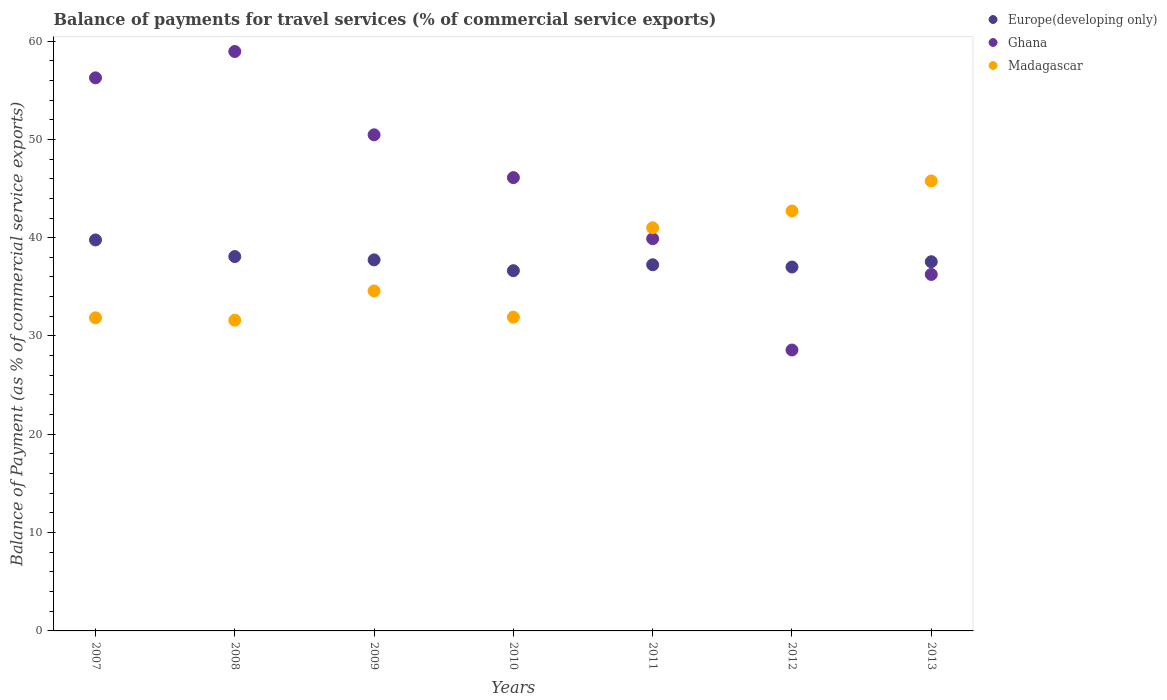How many different coloured dotlines are there?
Give a very brief answer. 3. Is the number of dotlines equal to the number of legend labels?
Provide a succinct answer. Yes. What is the balance of payments for travel services in Europe(developing only) in 2012?
Your answer should be very brief. 37.02. Across all years, what is the maximum balance of payments for travel services in Madagascar?
Provide a succinct answer. 45.77. Across all years, what is the minimum balance of payments for travel services in Europe(developing only)?
Keep it short and to the point. 36.64. In which year was the balance of payments for travel services in Ghana maximum?
Your answer should be very brief. 2008. What is the total balance of payments for travel services in Madagascar in the graph?
Ensure brevity in your answer.  259.44. What is the difference between the balance of payments for travel services in Ghana in 2007 and that in 2009?
Your response must be concise. 5.8. What is the difference between the balance of payments for travel services in Ghana in 2010 and the balance of payments for travel services in Madagascar in 2009?
Make the answer very short. 11.53. What is the average balance of payments for travel services in Madagascar per year?
Your response must be concise. 37.06. In the year 2009, what is the difference between the balance of payments for travel services in Ghana and balance of payments for travel services in Madagascar?
Your response must be concise. 15.88. What is the ratio of the balance of payments for travel services in Ghana in 2007 to that in 2012?
Make the answer very short. 1.97. Is the balance of payments for travel services in Madagascar in 2009 less than that in 2010?
Your response must be concise. No. What is the difference between the highest and the second highest balance of payments for travel services in Ghana?
Give a very brief answer. 2.68. What is the difference between the highest and the lowest balance of payments for travel services in Europe(developing only)?
Your answer should be very brief. 3.13. Is the sum of the balance of payments for travel services in Ghana in 2011 and 2012 greater than the maximum balance of payments for travel services in Madagascar across all years?
Your answer should be compact. Yes. Is it the case that in every year, the sum of the balance of payments for travel services in Madagascar and balance of payments for travel services in Ghana  is greater than the balance of payments for travel services in Europe(developing only)?
Give a very brief answer. Yes. Is the balance of payments for travel services in Madagascar strictly greater than the balance of payments for travel services in Europe(developing only) over the years?
Your response must be concise. No. Is the balance of payments for travel services in Europe(developing only) strictly less than the balance of payments for travel services in Madagascar over the years?
Offer a terse response. No. How many years are there in the graph?
Provide a succinct answer. 7. What is the difference between two consecutive major ticks on the Y-axis?
Your response must be concise. 10. Does the graph contain any zero values?
Offer a very short reply. No. Does the graph contain grids?
Provide a short and direct response. No. Where does the legend appear in the graph?
Provide a succinct answer. Top right. How are the legend labels stacked?
Give a very brief answer. Vertical. What is the title of the graph?
Offer a terse response. Balance of payments for travel services (% of commercial service exports). Does "Uruguay" appear as one of the legend labels in the graph?
Offer a very short reply. No. What is the label or title of the X-axis?
Give a very brief answer. Years. What is the label or title of the Y-axis?
Offer a terse response. Balance of Payment (as % of commercial service exports). What is the Balance of Payment (as % of commercial service exports) in Europe(developing only) in 2007?
Your answer should be compact. 39.77. What is the Balance of Payment (as % of commercial service exports) of Ghana in 2007?
Provide a succinct answer. 56.26. What is the Balance of Payment (as % of commercial service exports) of Madagascar in 2007?
Offer a very short reply. 31.85. What is the Balance of Payment (as % of commercial service exports) of Europe(developing only) in 2008?
Provide a succinct answer. 38.08. What is the Balance of Payment (as % of commercial service exports) in Ghana in 2008?
Give a very brief answer. 58.94. What is the Balance of Payment (as % of commercial service exports) in Madagascar in 2008?
Provide a succinct answer. 31.6. What is the Balance of Payment (as % of commercial service exports) of Europe(developing only) in 2009?
Ensure brevity in your answer.  37.74. What is the Balance of Payment (as % of commercial service exports) in Ghana in 2009?
Keep it short and to the point. 50.46. What is the Balance of Payment (as % of commercial service exports) of Madagascar in 2009?
Give a very brief answer. 34.58. What is the Balance of Payment (as % of commercial service exports) in Europe(developing only) in 2010?
Provide a succinct answer. 36.64. What is the Balance of Payment (as % of commercial service exports) of Ghana in 2010?
Your response must be concise. 46.11. What is the Balance of Payment (as % of commercial service exports) of Madagascar in 2010?
Provide a short and direct response. 31.92. What is the Balance of Payment (as % of commercial service exports) of Europe(developing only) in 2011?
Ensure brevity in your answer.  37.24. What is the Balance of Payment (as % of commercial service exports) of Ghana in 2011?
Keep it short and to the point. 39.89. What is the Balance of Payment (as % of commercial service exports) of Madagascar in 2011?
Your answer should be very brief. 41.01. What is the Balance of Payment (as % of commercial service exports) in Europe(developing only) in 2012?
Offer a very short reply. 37.02. What is the Balance of Payment (as % of commercial service exports) of Ghana in 2012?
Your answer should be compact. 28.57. What is the Balance of Payment (as % of commercial service exports) of Madagascar in 2012?
Offer a terse response. 42.72. What is the Balance of Payment (as % of commercial service exports) in Europe(developing only) in 2013?
Give a very brief answer. 37.55. What is the Balance of Payment (as % of commercial service exports) in Ghana in 2013?
Keep it short and to the point. 36.26. What is the Balance of Payment (as % of commercial service exports) in Madagascar in 2013?
Keep it short and to the point. 45.77. Across all years, what is the maximum Balance of Payment (as % of commercial service exports) of Europe(developing only)?
Provide a short and direct response. 39.77. Across all years, what is the maximum Balance of Payment (as % of commercial service exports) in Ghana?
Offer a terse response. 58.94. Across all years, what is the maximum Balance of Payment (as % of commercial service exports) in Madagascar?
Your answer should be compact. 45.77. Across all years, what is the minimum Balance of Payment (as % of commercial service exports) of Europe(developing only)?
Your answer should be compact. 36.64. Across all years, what is the minimum Balance of Payment (as % of commercial service exports) in Ghana?
Give a very brief answer. 28.57. Across all years, what is the minimum Balance of Payment (as % of commercial service exports) in Madagascar?
Make the answer very short. 31.6. What is the total Balance of Payment (as % of commercial service exports) in Europe(developing only) in the graph?
Your answer should be compact. 264.05. What is the total Balance of Payment (as % of commercial service exports) in Ghana in the graph?
Provide a short and direct response. 316.49. What is the total Balance of Payment (as % of commercial service exports) of Madagascar in the graph?
Give a very brief answer. 259.44. What is the difference between the Balance of Payment (as % of commercial service exports) of Europe(developing only) in 2007 and that in 2008?
Keep it short and to the point. 1.69. What is the difference between the Balance of Payment (as % of commercial service exports) in Ghana in 2007 and that in 2008?
Make the answer very short. -2.68. What is the difference between the Balance of Payment (as % of commercial service exports) in Madagascar in 2007 and that in 2008?
Provide a succinct answer. 0.24. What is the difference between the Balance of Payment (as % of commercial service exports) of Europe(developing only) in 2007 and that in 2009?
Your answer should be compact. 2.03. What is the difference between the Balance of Payment (as % of commercial service exports) in Ghana in 2007 and that in 2009?
Your answer should be compact. 5.8. What is the difference between the Balance of Payment (as % of commercial service exports) in Madagascar in 2007 and that in 2009?
Ensure brevity in your answer.  -2.73. What is the difference between the Balance of Payment (as % of commercial service exports) in Europe(developing only) in 2007 and that in 2010?
Make the answer very short. 3.13. What is the difference between the Balance of Payment (as % of commercial service exports) of Ghana in 2007 and that in 2010?
Keep it short and to the point. 10.15. What is the difference between the Balance of Payment (as % of commercial service exports) in Madagascar in 2007 and that in 2010?
Keep it short and to the point. -0.07. What is the difference between the Balance of Payment (as % of commercial service exports) of Europe(developing only) in 2007 and that in 2011?
Your answer should be very brief. 2.53. What is the difference between the Balance of Payment (as % of commercial service exports) of Ghana in 2007 and that in 2011?
Your response must be concise. 16.36. What is the difference between the Balance of Payment (as % of commercial service exports) of Madagascar in 2007 and that in 2011?
Provide a succinct answer. -9.16. What is the difference between the Balance of Payment (as % of commercial service exports) of Europe(developing only) in 2007 and that in 2012?
Make the answer very short. 2.75. What is the difference between the Balance of Payment (as % of commercial service exports) of Ghana in 2007 and that in 2012?
Your answer should be compact. 27.68. What is the difference between the Balance of Payment (as % of commercial service exports) in Madagascar in 2007 and that in 2012?
Your response must be concise. -10.87. What is the difference between the Balance of Payment (as % of commercial service exports) in Europe(developing only) in 2007 and that in 2013?
Give a very brief answer. 2.22. What is the difference between the Balance of Payment (as % of commercial service exports) in Ghana in 2007 and that in 2013?
Give a very brief answer. 20. What is the difference between the Balance of Payment (as % of commercial service exports) of Madagascar in 2007 and that in 2013?
Your response must be concise. -13.92. What is the difference between the Balance of Payment (as % of commercial service exports) of Europe(developing only) in 2008 and that in 2009?
Offer a very short reply. 0.34. What is the difference between the Balance of Payment (as % of commercial service exports) in Ghana in 2008 and that in 2009?
Make the answer very short. 8.47. What is the difference between the Balance of Payment (as % of commercial service exports) in Madagascar in 2008 and that in 2009?
Your response must be concise. -2.97. What is the difference between the Balance of Payment (as % of commercial service exports) of Europe(developing only) in 2008 and that in 2010?
Give a very brief answer. 1.44. What is the difference between the Balance of Payment (as % of commercial service exports) in Ghana in 2008 and that in 2010?
Your response must be concise. 12.83. What is the difference between the Balance of Payment (as % of commercial service exports) of Madagascar in 2008 and that in 2010?
Your response must be concise. -0.31. What is the difference between the Balance of Payment (as % of commercial service exports) of Europe(developing only) in 2008 and that in 2011?
Your answer should be compact. 0.84. What is the difference between the Balance of Payment (as % of commercial service exports) of Ghana in 2008 and that in 2011?
Your answer should be very brief. 19.04. What is the difference between the Balance of Payment (as % of commercial service exports) in Madagascar in 2008 and that in 2011?
Your answer should be compact. -9.4. What is the difference between the Balance of Payment (as % of commercial service exports) of Europe(developing only) in 2008 and that in 2012?
Give a very brief answer. 1.06. What is the difference between the Balance of Payment (as % of commercial service exports) of Ghana in 2008 and that in 2012?
Offer a very short reply. 30.36. What is the difference between the Balance of Payment (as % of commercial service exports) in Madagascar in 2008 and that in 2012?
Give a very brief answer. -11.11. What is the difference between the Balance of Payment (as % of commercial service exports) in Europe(developing only) in 2008 and that in 2013?
Give a very brief answer. 0.53. What is the difference between the Balance of Payment (as % of commercial service exports) in Ghana in 2008 and that in 2013?
Make the answer very short. 22.68. What is the difference between the Balance of Payment (as % of commercial service exports) in Madagascar in 2008 and that in 2013?
Ensure brevity in your answer.  -14.17. What is the difference between the Balance of Payment (as % of commercial service exports) in Europe(developing only) in 2009 and that in 2010?
Give a very brief answer. 1.1. What is the difference between the Balance of Payment (as % of commercial service exports) of Ghana in 2009 and that in 2010?
Provide a succinct answer. 4.35. What is the difference between the Balance of Payment (as % of commercial service exports) in Madagascar in 2009 and that in 2010?
Offer a very short reply. 2.66. What is the difference between the Balance of Payment (as % of commercial service exports) of Europe(developing only) in 2009 and that in 2011?
Offer a very short reply. 0.5. What is the difference between the Balance of Payment (as % of commercial service exports) of Ghana in 2009 and that in 2011?
Ensure brevity in your answer.  10.57. What is the difference between the Balance of Payment (as % of commercial service exports) of Madagascar in 2009 and that in 2011?
Make the answer very short. -6.43. What is the difference between the Balance of Payment (as % of commercial service exports) of Europe(developing only) in 2009 and that in 2012?
Make the answer very short. 0.73. What is the difference between the Balance of Payment (as % of commercial service exports) in Ghana in 2009 and that in 2012?
Your answer should be compact. 21.89. What is the difference between the Balance of Payment (as % of commercial service exports) of Madagascar in 2009 and that in 2012?
Keep it short and to the point. -8.14. What is the difference between the Balance of Payment (as % of commercial service exports) of Europe(developing only) in 2009 and that in 2013?
Give a very brief answer. 0.19. What is the difference between the Balance of Payment (as % of commercial service exports) of Ghana in 2009 and that in 2013?
Give a very brief answer. 14.2. What is the difference between the Balance of Payment (as % of commercial service exports) of Madagascar in 2009 and that in 2013?
Give a very brief answer. -11.19. What is the difference between the Balance of Payment (as % of commercial service exports) in Europe(developing only) in 2010 and that in 2011?
Ensure brevity in your answer.  -0.6. What is the difference between the Balance of Payment (as % of commercial service exports) of Ghana in 2010 and that in 2011?
Provide a short and direct response. 6.21. What is the difference between the Balance of Payment (as % of commercial service exports) in Madagascar in 2010 and that in 2011?
Make the answer very short. -9.09. What is the difference between the Balance of Payment (as % of commercial service exports) in Europe(developing only) in 2010 and that in 2012?
Keep it short and to the point. -0.37. What is the difference between the Balance of Payment (as % of commercial service exports) of Ghana in 2010 and that in 2012?
Ensure brevity in your answer.  17.53. What is the difference between the Balance of Payment (as % of commercial service exports) in Madagascar in 2010 and that in 2012?
Offer a terse response. -10.8. What is the difference between the Balance of Payment (as % of commercial service exports) of Europe(developing only) in 2010 and that in 2013?
Your answer should be compact. -0.91. What is the difference between the Balance of Payment (as % of commercial service exports) in Ghana in 2010 and that in 2013?
Your response must be concise. 9.85. What is the difference between the Balance of Payment (as % of commercial service exports) of Madagascar in 2010 and that in 2013?
Offer a terse response. -13.85. What is the difference between the Balance of Payment (as % of commercial service exports) in Europe(developing only) in 2011 and that in 2012?
Your answer should be very brief. 0.23. What is the difference between the Balance of Payment (as % of commercial service exports) in Ghana in 2011 and that in 2012?
Offer a terse response. 11.32. What is the difference between the Balance of Payment (as % of commercial service exports) of Madagascar in 2011 and that in 2012?
Offer a very short reply. -1.71. What is the difference between the Balance of Payment (as % of commercial service exports) in Europe(developing only) in 2011 and that in 2013?
Give a very brief answer. -0.31. What is the difference between the Balance of Payment (as % of commercial service exports) of Ghana in 2011 and that in 2013?
Your response must be concise. 3.63. What is the difference between the Balance of Payment (as % of commercial service exports) of Madagascar in 2011 and that in 2013?
Provide a succinct answer. -4.76. What is the difference between the Balance of Payment (as % of commercial service exports) of Europe(developing only) in 2012 and that in 2013?
Make the answer very short. -0.54. What is the difference between the Balance of Payment (as % of commercial service exports) of Ghana in 2012 and that in 2013?
Provide a short and direct response. -7.69. What is the difference between the Balance of Payment (as % of commercial service exports) of Madagascar in 2012 and that in 2013?
Provide a short and direct response. -3.05. What is the difference between the Balance of Payment (as % of commercial service exports) in Europe(developing only) in 2007 and the Balance of Payment (as % of commercial service exports) in Ghana in 2008?
Provide a short and direct response. -19.17. What is the difference between the Balance of Payment (as % of commercial service exports) in Europe(developing only) in 2007 and the Balance of Payment (as % of commercial service exports) in Madagascar in 2008?
Your answer should be compact. 8.17. What is the difference between the Balance of Payment (as % of commercial service exports) of Ghana in 2007 and the Balance of Payment (as % of commercial service exports) of Madagascar in 2008?
Your answer should be very brief. 24.65. What is the difference between the Balance of Payment (as % of commercial service exports) of Europe(developing only) in 2007 and the Balance of Payment (as % of commercial service exports) of Ghana in 2009?
Give a very brief answer. -10.69. What is the difference between the Balance of Payment (as % of commercial service exports) in Europe(developing only) in 2007 and the Balance of Payment (as % of commercial service exports) in Madagascar in 2009?
Give a very brief answer. 5.19. What is the difference between the Balance of Payment (as % of commercial service exports) in Ghana in 2007 and the Balance of Payment (as % of commercial service exports) in Madagascar in 2009?
Offer a very short reply. 21.68. What is the difference between the Balance of Payment (as % of commercial service exports) in Europe(developing only) in 2007 and the Balance of Payment (as % of commercial service exports) in Ghana in 2010?
Provide a short and direct response. -6.34. What is the difference between the Balance of Payment (as % of commercial service exports) of Europe(developing only) in 2007 and the Balance of Payment (as % of commercial service exports) of Madagascar in 2010?
Provide a short and direct response. 7.85. What is the difference between the Balance of Payment (as % of commercial service exports) of Ghana in 2007 and the Balance of Payment (as % of commercial service exports) of Madagascar in 2010?
Make the answer very short. 24.34. What is the difference between the Balance of Payment (as % of commercial service exports) in Europe(developing only) in 2007 and the Balance of Payment (as % of commercial service exports) in Ghana in 2011?
Your response must be concise. -0.13. What is the difference between the Balance of Payment (as % of commercial service exports) of Europe(developing only) in 2007 and the Balance of Payment (as % of commercial service exports) of Madagascar in 2011?
Ensure brevity in your answer.  -1.24. What is the difference between the Balance of Payment (as % of commercial service exports) in Ghana in 2007 and the Balance of Payment (as % of commercial service exports) in Madagascar in 2011?
Provide a short and direct response. 15.25. What is the difference between the Balance of Payment (as % of commercial service exports) of Europe(developing only) in 2007 and the Balance of Payment (as % of commercial service exports) of Ghana in 2012?
Your answer should be very brief. 11.2. What is the difference between the Balance of Payment (as % of commercial service exports) of Europe(developing only) in 2007 and the Balance of Payment (as % of commercial service exports) of Madagascar in 2012?
Provide a succinct answer. -2.95. What is the difference between the Balance of Payment (as % of commercial service exports) in Ghana in 2007 and the Balance of Payment (as % of commercial service exports) in Madagascar in 2012?
Offer a terse response. 13.54. What is the difference between the Balance of Payment (as % of commercial service exports) in Europe(developing only) in 2007 and the Balance of Payment (as % of commercial service exports) in Ghana in 2013?
Ensure brevity in your answer.  3.51. What is the difference between the Balance of Payment (as % of commercial service exports) in Europe(developing only) in 2007 and the Balance of Payment (as % of commercial service exports) in Madagascar in 2013?
Keep it short and to the point. -6. What is the difference between the Balance of Payment (as % of commercial service exports) in Ghana in 2007 and the Balance of Payment (as % of commercial service exports) in Madagascar in 2013?
Provide a succinct answer. 10.49. What is the difference between the Balance of Payment (as % of commercial service exports) of Europe(developing only) in 2008 and the Balance of Payment (as % of commercial service exports) of Ghana in 2009?
Make the answer very short. -12.38. What is the difference between the Balance of Payment (as % of commercial service exports) of Europe(developing only) in 2008 and the Balance of Payment (as % of commercial service exports) of Madagascar in 2009?
Keep it short and to the point. 3.5. What is the difference between the Balance of Payment (as % of commercial service exports) of Ghana in 2008 and the Balance of Payment (as % of commercial service exports) of Madagascar in 2009?
Provide a succinct answer. 24.36. What is the difference between the Balance of Payment (as % of commercial service exports) in Europe(developing only) in 2008 and the Balance of Payment (as % of commercial service exports) in Ghana in 2010?
Keep it short and to the point. -8.03. What is the difference between the Balance of Payment (as % of commercial service exports) of Europe(developing only) in 2008 and the Balance of Payment (as % of commercial service exports) of Madagascar in 2010?
Your answer should be compact. 6.16. What is the difference between the Balance of Payment (as % of commercial service exports) of Ghana in 2008 and the Balance of Payment (as % of commercial service exports) of Madagascar in 2010?
Make the answer very short. 27.02. What is the difference between the Balance of Payment (as % of commercial service exports) in Europe(developing only) in 2008 and the Balance of Payment (as % of commercial service exports) in Ghana in 2011?
Your response must be concise. -1.81. What is the difference between the Balance of Payment (as % of commercial service exports) in Europe(developing only) in 2008 and the Balance of Payment (as % of commercial service exports) in Madagascar in 2011?
Offer a very short reply. -2.93. What is the difference between the Balance of Payment (as % of commercial service exports) in Ghana in 2008 and the Balance of Payment (as % of commercial service exports) in Madagascar in 2011?
Ensure brevity in your answer.  17.93. What is the difference between the Balance of Payment (as % of commercial service exports) in Europe(developing only) in 2008 and the Balance of Payment (as % of commercial service exports) in Ghana in 2012?
Your answer should be compact. 9.51. What is the difference between the Balance of Payment (as % of commercial service exports) of Europe(developing only) in 2008 and the Balance of Payment (as % of commercial service exports) of Madagascar in 2012?
Your answer should be compact. -4.64. What is the difference between the Balance of Payment (as % of commercial service exports) of Ghana in 2008 and the Balance of Payment (as % of commercial service exports) of Madagascar in 2012?
Your answer should be compact. 16.22. What is the difference between the Balance of Payment (as % of commercial service exports) in Europe(developing only) in 2008 and the Balance of Payment (as % of commercial service exports) in Ghana in 2013?
Offer a terse response. 1.82. What is the difference between the Balance of Payment (as % of commercial service exports) in Europe(developing only) in 2008 and the Balance of Payment (as % of commercial service exports) in Madagascar in 2013?
Offer a terse response. -7.69. What is the difference between the Balance of Payment (as % of commercial service exports) of Ghana in 2008 and the Balance of Payment (as % of commercial service exports) of Madagascar in 2013?
Ensure brevity in your answer.  13.17. What is the difference between the Balance of Payment (as % of commercial service exports) in Europe(developing only) in 2009 and the Balance of Payment (as % of commercial service exports) in Ghana in 2010?
Your response must be concise. -8.36. What is the difference between the Balance of Payment (as % of commercial service exports) in Europe(developing only) in 2009 and the Balance of Payment (as % of commercial service exports) in Madagascar in 2010?
Give a very brief answer. 5.83. What is the difference between the Balance of Payment (as % of commercial service exports) in Ghana in 2009 and the Balance of Payment (as % of commercial service exports) in Madagascar in 2010?
Make the answer very short. 18.55. What is the difference between the Balance of Payment (as % of commercial service exports) in Europe(developing only) in 2009 and the Balance of Payment (as % of commercial service exports) in Ghana in 2011?
Make the answer very short. -2.15. What is the difference between the Balance of Payment (as % of commercial service exports) of Europe(developing only) in 2009 and the Balance of Payment (as % of commercial service exports) of Madagascar in 2011?
Your answer should be very brief. -3.26. What is the difference between the Balance of Payment (as % of commercial service exports) of Ghana in 2009 and the Balance of Payment (as % of commercial service exports) of Madagascar in 2011?
Provide a succinct answer. 9.46. What is the difference between the Balance of Payment (as % of commercial service exports) in Europe(developing only) in 2009 and the Balance of Payment (as % of commercial service exports) in Ghana in 2012?
Provide a succinct answer. 9.17. What is the difference between the Balance of Payment (as % of commercial service exports) in Europe(developing only) in 2009 and the Balance of Payment (as % of commercial service exports) in Madagascar in 2012?
Keep it short and to the point. -4.97. What is the difference between the Balance of Payment (as % of commercial service exports) in Ghana in 2009 and the Balance of Payment (as % of commercial service exports) in Madagascar in 2012?
Your answer should be very brief. 7.75. What is the difference between the Balance of Payment (as % of commercial service exports) in Europe(developing only) in 2009 and the Balance of Payment (as % of commercial service exports) in Ghana in 2013?
Keep it short and to the point. 1.48. What is the difference between the Balance of Payment (as % of commercial service exports) of Europe(developing only) in 2009 and the Balance of Payment (as % of commercial service exports) of Madagascar in 2013?
Offer a terse response. -8.03. What is the difference between the Balance of Payment (as % of commercial service exports) of Ghana in 2009 and the Balance of Payment (as % of commercial service exports) of Madagascar in 2013?
Offer a terse response. 4.69. What is the difference between the Balance of Payment (as % of commercial service exports) of Europe(developing only) in 2010 and the Balance of Payment (as % of commercial service exports) of Ghana in 2011?
Ensure brevity in your answer.  -3.25. What is the difference between the Balance of Payment (as % of commercial service exports) of Europe(developing only) in 2010 and the Balance of Payment (as % of commercial service exports) of Madagascar in 2011?
Offer a very short reply. -4.37. What is the difference between the Balance of Payment (as % of commercial service exports) of Ghana in 2010 and the Balance of Payment (as % of commercial service exports) of Madagascar in 2011?
Your answer should be very brief. 5.1. What is the difference between the Balance of Payment (as % of commercial service exports) of Europe(developing only) in 2010 and the Balance of Payment (as % of commercial service exports) of Ghana in 2012?
Your answer should be compact. 8.07. What is the difference between the Balance of Payment (as % of commercial service exports) of Europe(developing only) in 2010 and the Balance of Payment (as % of commercial service exports) of Madagascar in 2012?
Keep it short and to the point. -6.07. What is the difference between the Balance of Payment (as % of commercial service exports) of Ghana in 2010 and the Balance of Payment (as % of commercial service exports) of Madagascar in 2012?
Ensure brevity in your answer.  3.39. What is the difference between the Balance of Payment (as % of commercial service exports) in Europe(developing only) in 2010 and the Balance of Payment (as % of commercial service exports) in Ghana in 2013?
Offer a terse response. 0.38. What is the difference between the Balance of Payment (as % of commercial service exports) of Europe(developing only) in 2010 and the Balance of Payment (as % of commercial service exports) of Madagascar in 2013?
Give a very brief answer. -9.13. What is the difference between the Balance of Payment (as % of commercial service exports) in Ghana in 2010 and the Balance of Payment (as % of commercial service exports) in Madagascar in 2013?
Your response must be concise. 0.34. What is the difference between the Balance of Payment (as % of commercial service exports) in Europe(developing only) in 2011 and the Balance of Payment (as % of commercial service exports) in Ghana in 2012?
Keep it short and to the point. 8.67. What is the difference between the Balance of Payment (as % of commercial service exports) of Europe(developing only) in 2011 and the Balance of Payment (as % of commercial service exports) of Madagascar in 2012?
Offer a terse response. -5.47. What is the difference between the Balance of Payment (as % of commercial service exports) in Ghana in 2011 and the Balance of Payment (as % of commercial service exports) in Madagascar in 2012?
Give a very brief answer. -2.82. What is the difference between the Balance of Payment (as % of commercial service exports) in Europe(developing only) in 2011 and the Balance of Payment (as % of commercial service exports) in Ghana in 2013?
Make the answer very short. 0.98. What is the difference between the Balance of Payment (as % of commercial service exports) of Europe(developing only) in 2011 and the Balance of Payment (as % of commercial service exports) of Madagascar in 2013?
Make the answer very short. -8.53. What is the difference between the Balance of Payment (as % of commercial service exports) of Ghana in 2011 and the Balance of Payment (as % of commercial service exports) of Madagascar in 2013?
Your response must be concise. -5.88. What is the difference between the Balance of Payment (as % of commercial service exports) in Europe(developing only) in 2012 and the Balance of Payment (as % of commercial service exports) in Ghana in 2013?
Provide a succinct answer. 0.76. What is the difference between the Balance of Payment (as % of commercial service exports) in Europe(developing only) in 2012 and the Balance of Payment (as % of commercial service exports) in Madagascar in 2013?
Keep it short and to the point. -8.75. What is the difference between the Balance of Payment (as % of commercial service exports) of Ghana in 2012 and the Balance of Payment (as % of commercial service exports) of Madagascar in 2013?
Give a very brief answer. -17.2. What is the average Balance of Payment (as % of commercial service exports) of Europe(developing only) per year?
Your answer should be very brief. 37.72. What is the average Balance of Payment (as % of commercial service exports) of Ghana per year?
Provide a short and direct response. 45.21. What is the average Balance of Payment (as % of commercial service exports) of Madagascar per year?
Provide a short and direct response. 37.06. In the year 2007, what is the difference between the Balance of Payment (as % of commercial service exports) of Europe(developing only) and Balance of Payment (as % of commercial service exports) of Ghana?
Offer a very short reply. -16.49. In the year 2007, what is the difference between the Balance of Payment (as % of commercial service exports) of Europe(developing only) and Balance of Payment (as % of commercial service exports) of Madagascar?
Offer a very short reply. 7.92. In the year 2007, what is the difference between the Balance of Payment (as % of commercial service exports) in Ghana and Balance of Payment (as % of commercial service exports) in Madagascar?
Make the answer very short. 24.41. In the year 2008, what is the difference between the Balance of Payment (as % of commercial service exports) of Europe(developing only) and Balance of Payment (as % of commercial service exports) of Ghana?
Your answer should be compact. -20.86. In the year 2008, what is the difference between the Balance of Payment (as % of commercial service exports) of Europe(developing only) and Balance of Payment (as % of commercial service exports) of Madagascar?
Offer a terse response. 6.48. In the year 2008, what is the difference between the Balance of Payment (as % of commercial service exports) in Ghana and Balance of Payment (as % of commercial service exports) in Madagascar?
Your response must be concise. 27.33. In the year 2009, what is the difference between the Balance of Payment (as % of commercial service exports) of Europe(developing only) and Balance of Payment (as % of commercial service exports) of Ghana?
Your response must be concise. -12.72. In the year 2009, what is the difference between the Balance of Payment (as % of commercial service exports) in Europe(developing only) and Balance of Payment (as % of commercial service exports) in Madagascar?
Offer a very short reply. 3.16. In the year 2009, what is the difference between the Balance of Payment (as % of commercial service exports) of Ghana and Balance of Payment (as % of commercial service exports) of Madagascar?
Provide a short and direct response. 15.88. In the year 2010, what is the difference between the Balance of Payment (as % of commercial service exports) of Europe(developing only) and Balance of Payment (as % of commercial service exports) of Ghana?
Offer a very short reply. -9.47. In the year 2010, what is the difference between the Balance of Payment (as % of commercial service exports) of Europe(developing only) and Balance of Payment (as % of commercial service exports) of Madagascar?
Make the answer very short. 4.73. In the year 2010, what is the difference between the Balance of Payment (as % of commercial service exports) of Ghana and Balance of Payment (as % of commercial service exports) of Madagascar?
Your answer should be very brief. 14.19. In the year 2011, what is the difference between the Balance of Payment (as % of commercial service exports) in Europe(developing only) and Balance of Payment (as % of commercial service exports) in Ghana?
Make the answer very short. -2.65. In the year 2011, what is the difference between the Balance of Payment (as % of commercial service exports) in Europe(developing only) and Balance of Payment (as % of commercial service exports) in Madagascar?
Make the answer very short. -3.76. In the year 2011, what is the difference between the Balance of Payment (as % of commercial service exports) of Ghana and Balance of Payment (as % of commercial service exports) of Madagascar?
Provide a succinct answer. -1.11. In the year 2012, what is the difference between the Balance of Payment (as % of commercial service exports) in Europe(developing only) and Balance of Payment (as % of commercial service exports) in Ghana?
Your response must be concise. 8.44. In the year 2012, what is the difference between the Balance of Payment (as % of commercial service exports) of Europe(developing only) and Balance of Payment (as % of commercial service exports) of Madagascar?
Provide a short and direct response. -5.7. In the year 2012, what is the difference between the Balance of Payment (as % of commercial service exports) of Ghana and Balance of Payment (as % of commercial service exports) of Madagascar?
Provide a succinct answer. -14.14. In the year 2013, what is the difference between the Balance of Payment (as % of commercial service exports) of Europe(developing only) and Balance of Payment (as % of commercial service exports) of Ghana?
Ensure brevity in your answer.  1.29. In the year 2013, what is the difference between the Balance of Payment (as % of commercial service exports) of Europe(developing only) and Balance of Payment (as % of commercial service exports) of Madagascar?
Make the answer very short. -8.22. In the year 2013, what is the difference between the Balance of Payment (as % of commercial service exports) of Ghana and Balance of Payment (as % of commercial service exports) of Madagascar?
Your response must be concise. -9.51. What is the ratio of the Balance of Payment (as % of commercial service exports) in Europe(developing only) in 2007 to that in 2008?
Ensure brevity in your answer.  1.04. What is the ratio of the Balance of Payment (as % of commercial service exports) of Ghana in 2007 to that in 2008?
Give a very brief answer. 0.95. What is the ratio of the Balance of Payment (as % of commercial service exports) in Madagascar in 2007 to that in 2008?
Your answer should be compact. 1.01. What is the ratio of the Balance of Payment (as % of commercial service exports) in Europe(developing only) in 2007 to that in 2009?
Make the answer very short. 1.05. What is the ratio of the Balance of Payment (as % of commercial service exports) of Ghana in 2007 to that in 2009?
Ensure brevity in your answer.  1.11. What is the ratio of the Balance of Payment (as % of commercial service exports) in Madagascar in 2007 to that in 2009?
Offer a terse response. 0.92. What is the ratio of the Balance of Payment (as % of commercial service exports) of Europe(developing only) in 2007 to that in 2010?
Provide a short and direct response. 1.09. What is the ratio of the Balance of Payment (as % of commercial service exports) of Ghana in 2007 to that in 2010?
Your response must be concise. 1.22. What is the ratio of the Balance of Payment (as % of commercial service exports) in Europe(developing only) in 2007 to that in 2011?
Make the answer very short. 1.07. What is the ratio of the Balance of Payment (as % of commercial service exports) in Ghana in 2007 to that in 2011?
Your response must be concise. 1.41. What is the ratio of the Balance of Payment (as % of commercial service exports) in Madagascar in 2007 to that in 2011?
Provide a short and direct response. 0.78. What is the ratio of the Balance of Payment (as % of commercial service exports) of Europe(developing only) in 2007 to that in 2012?
Your answer should be very brief. 1.07. What is the ratio of the Balance of Payment (as % of commercial service exports) of Ghana in 2007 to that in 2012?
Provide a succinct answer. 1.97. What is the ratio of the Balance of Payment (as % of commercial service exports) in Madagascar in 2007 to that in 2012?
Offer a very short reply. 0.75. What is the ratio of the Balance of Payment (as % of commercial service exports) of Europe(developing only) in 2007 to that in 2013?
Keep it short and to the point. 1.06. What is the ratio of the Balance of Payment (as % of commercial service exports) of Ghana in 2007 to that in 2013?
Offer a terse response. 1.55. What is the ratio of the Balance of Payment (as % of commercial service exports) in Madagascar in 2007 to that in 2013?
Keep it short and to the point. 0.7. What is the ratio of the Balance of Payment (as % of commercial service exports) of Europe(developing only) in 2008 to that in 2009?
Offer a very short reply. 1.01. What is the ratio of the Balance of Payment (as % of commercial service exports) in Ghana in 2008 to that in 2009?
Offer a terse response. 1.17. What is the ratio of the Balance of Payment (as % of commercial service exports) in Madagascar in 2008 to that in 2009?
Make the answer very short. 0.91. What is the ratio of the Balance of Payment (as % of commercial service exports) of Europe(developing only) in 2008 to that in 2010?
Offer a very short reply. 1.04. What is the ratio of the Balance of Payment (as % of commercial service exports) in Ghana in 2008 to that in 2010?
Your answer should be compact. 1.28. What is the ratio of the Balance of Payment (as % of commercial service exports) of Madagascar in 2008 to that in 2010?
Make the answer very short. 0.99. What is the ratio of the Balance of Payment (as % of commercial service exports) of Europe(developing only) in 2008 to that in 2011?
Keep it short and to the point. 1.02. What is the ratio of the Balance of Payment (as % of commercial service exports) in Ghana in 2008 to that in 2011?
Give a very brief answer. 1.48. What is the ratio of the Balance of Payment (as % of commercial service exports) in Madagascar in 2008 to that in 2011?
Your answer should be compact. 0.77. What is the ratio of the Balance of Payment (as % of commercial service exports) in Europe(developing only) in 2008 to that in 2012?
Provide a succinct answer. 1.03. What is the ratio of the Balance of Payment (as % of commercial service exports) in Ghana in 2008 to that in 2012?
Provide a succinct answer. 2.06. What is the ratio of the Balance of Payment (as % of commercial service exports) in Madagascar in 2008 to that in 2012?
Ensure brevity in your answer.  0.74. What is the ratio of the Balance of Payment (as % of commercial service exports) in Ghana in 2008 to that in 2013?
Offer a terse response. 1.63. What is the ratio of the Balance of Payment (as % of commercial service exports) in Madagascar in 2008 to that in 2013?
Ensure brevity in your answer.  0.69. What is the ratio of the Balance of Payment (as % of commercial service exports) of Europe(developing only) in 2009 to that in 2010?
Ensure brevity in your answer.  1.03. What is the ratio of the Balance of Payment (as % of commercial service exports) of Ghana in 2009 to that in 2010?
Provide a short and direct response. 1.09. What is the ratio of the Balance of Payment (as % of commercial service exports) of Madagascar in 2009 to that in 2010?
Your response must be concise. 1.08. What is the ratio of the Balance of Payment (as % of commercial service exports) of Europe(developing only) in 2009 to that in 2011?
Provide a short and direct response. 1.01. What is the ratio of the Balance of Payment (as % of commercial service exports) in Ghana in 2009 to that in 2011?
Make the answer very short. 1.26. What is the ratio of the Balance of Payment (as % of commercial service exports) of Madagascar in 2009 to that in 2011?
Provide a succinct answer. 0.84. What is the ratio of the Balance of Payment (as % of commercial service exports) in Europe(developing only) in 2009 to that in 2012?
Offer a terse response. 1.02. What is the ratio of the Balance of Payment (as % of commercial service exports) of Ghana in 2009 to that in 2012?
Provide a succinct answer. 1.77. What is the ratio of the Balance of Payment (as % of commercial service exports) of Madagascar in 2009 to that in 2012?
Provide a succinct answer. 0.81. What is the ratio of the Balance of Payment (as % of commercial service exports) in Ghana in 2009 to that in 2013?
Give a very brief answer. 1.39. What is the ratio of the Balance of Payment (as % of commercial service exports) in Madagascar in 2009 to that in 2013?
Offer a terse response. 0.76. What is the ratio of the Balance of Payment (as % of commercial service exports) of Europe(developing only) in 2010 to that in 2011?
Give a very brief answer. 0.98. What is the ratio of the Balance of Payment (as % of commercial service exports) in Ghana in 2010 to that in 2011?
Your answer should be compact. 1.16. What is the ratio of the Balance of Payment (as % of commercial service exports) in Madagascar in 2010 to that in 2011?
Give a very brief answer. 0.78. What is the ratio of the Balance of Payment (as % of commercial service exports) in Ghana in 2010 to that in 2012?
Give a very brief answer. 1.61. What is the ratio of the Balance of Payment (as % of commercial service exports) of Madagascar in 2010 to that in 2012?
Give a very brief answer. 0.75. What is the ratio of the Balance of Payment (as % of commercial service exports) of Europe(developing only) in 2010 to that in 2013?
Keep it short and to the point. 0.98. What is the ratio of the Balance of Payment (as % of commercial service exports) in Ghana in 2010 to that in 2013?
Offer a terse response. 1.27. What is the ratio of the Balance of Payment (as % of commercial service exports) in Madagascar in 2010 to that in 2013?
Your answer should be very brief. 0.7. What is the ratio of the Balance of Payment (as % of commercial service exports) of Europe(developing only) in 2011 to that in 2012?
Your answer should be very brief. 1.01. What is the ratio of the Balance of Payment (as % of commercial service exports) in Ghana in 2011 to that in 2012?
Provide a succinct answer. 1.4. What is the ratio of the Balance of Payment (as % of commercial service exports) in Madagascar in 2011 to that in 2012?
Give a very brief answer. 0.96. What is the ratio of the Balance of Payment (as % of commercial service exports) in Ghana in 2011 to that in 2013?
Offer a terse response. 1.1. What is the ratio of the Balance of Payment (as % of commercial service exports) of Madagascar in 2011 to that in 2013?
Offer a very short reply. 0.9. What is the ratio of the Balance of Payment (as % of commercial service exports) in Europe(developing only) in 2012 to that in 2013?
Your response must be concise. 0.99. What is the ratio of the Balance of Payment (as % of commercial service exports) of Ghana in 2012 to that in 2013?
Your answer should be compact. 0.79. What is the difference between the highest and the second highest Balance of Payment (as % of commercial service exports) in Europe(developing only)?
Ensure brevity in your answer.  1.69. What is the difference between the highest and the second highest Balance of Payment (as % of commercial service exports) in Ghana?
Keep it short and to the point. 2.68. What is the difference between the highest and the second highest Balance of Payment (as % of commercial service exports) of Madagascar?
Offer a very short reply. 3.05. What is the difference between the highest and the lowest Balance of Payment (as % of commercial service exports) in Europe(developing only)?
Make the answer very short. 3.13. What is the difference between the highest and the lowest Balance of Payment (as % of commercial service exports) of Ghana?
Provide a short and direct response. 30.36. What is the difference between the highest and the lowest Balance of Payment (as % of commercial service exports) of Madagascar?
Ensure brevity in your answer.  14.17. 